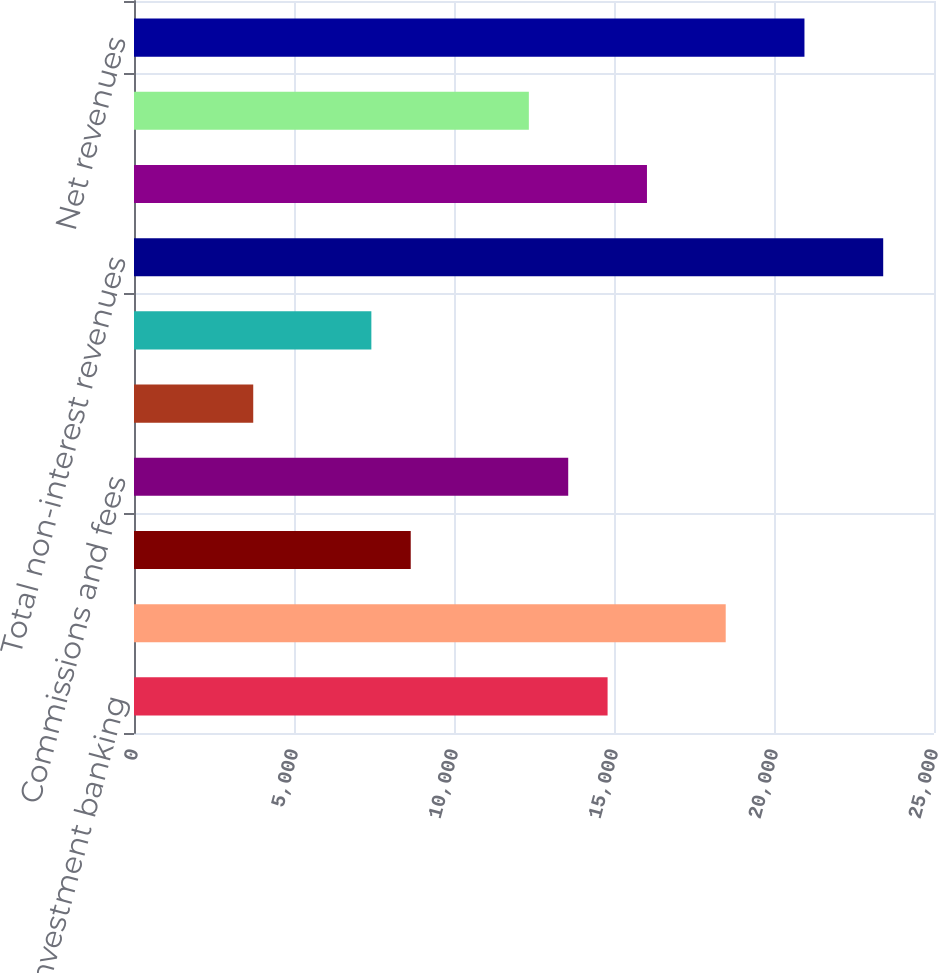<chart> <loc_0><loc_0><loc_500><loc_500><bar_chart><fcel>Investment banking<fcel>Trading<fcel>Investments<fcel>Commissions and fees<fcel>Asset management distribution<fcel>Other<fcel>Total non-interest revenues<fcel>Interest income<fcel>Net interest<fcel>Net revenues<nl><fcel>14799.8<fcel>18491<fcel>8647.8<fcel>13569.4<fcel>3726.2<fcel>7417.4<fcel>23412.6<fcel>16030.2<fcel>12339<fcel>20951.8<nl></chart> 